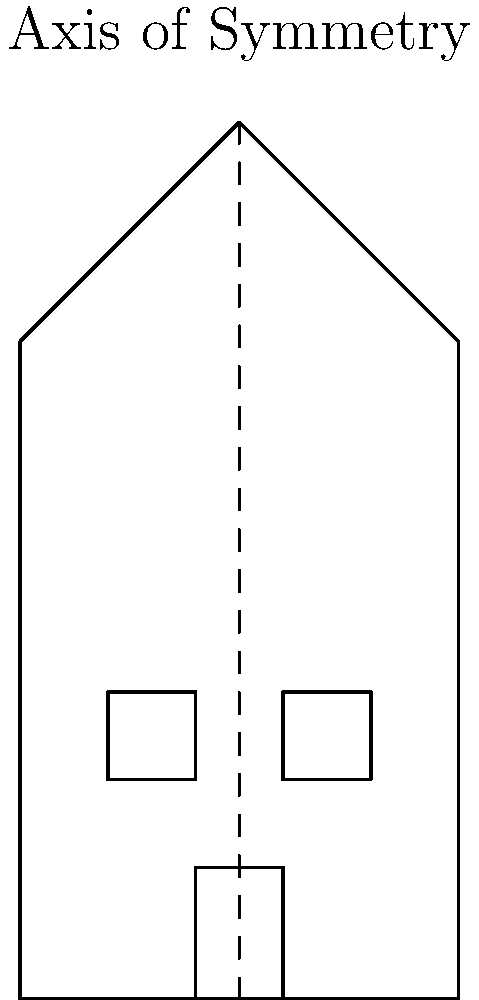Examine the front elevation drawing of this notable Berkeley building. Identify the number of symmetrical elements present in the design with respect to the vertical axis of symmetry. To determine the number of symmetrical elements in this building design, let's analyze each component with respect to the vertical axis of symmetry:

1. Overall shape: The building's outline is symmetrical. The left half mirrors the right half along the central vertical axis.

2. Roof: The triangular roof is symmetrical, with its peak aligned with the axis of symmetry.

3. Windows: There are two identical rectangular windows, one on each side of the axis of symmetry. They are placed at the same height and have the same dimensions.

4. Door: The rectangular door is centered on the axis of symmetry, making it a symmetrical element.

5. Facade: The overall facade, including the placement of windows and door, is symmetrical.

In total, we can identify 5 distinct symmetrical elements in this design: the overall shape, roof, windows (as a pair), door, and facade composition.
Answer: 5 symmetrical elements 